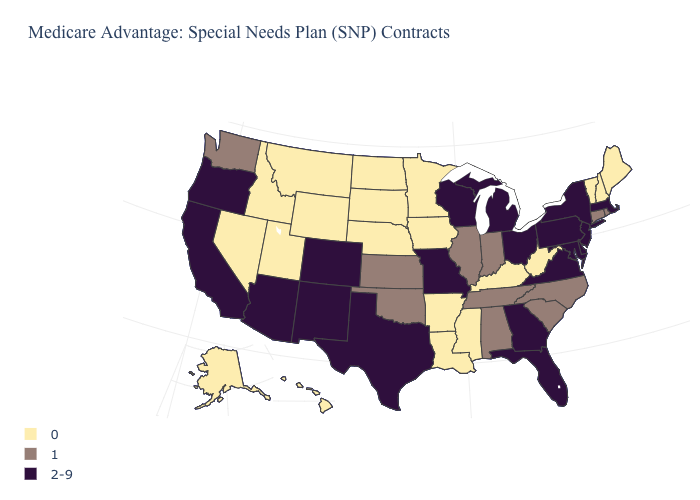Does North Carolina have a lower value than Massachusetts?
Short answer required. Yes. Among the states that border Maryland , which have the highest value?
Short answer required. Delaware, Pennsylvania, Virginia. Name the states that have a value in the range 0?
Quick response, please. Alaska, Arkansas, Hawaii, Iowa, Idaho, Kentucky, Louisiana, Maine, Minnesota, Mississippi, Montana, North Dakota, Nebraska, New Hampshire, Nevada, South Dakota, Utah, Vermont, West Virginia, Wyoming. Name the states that have a value in the range 1?
Keep it brief. Alabama, Connecticut, Illinois, Indiana, Kansas, North Carolina, Oklahoma, Rhode Island, South Carolina, Tennessee, Washington. Name the states that have a value in the range 0?
Be succinct. Alaska, Arkansas, Hawaii, Iowa, Idaho, Kentucky, Louisiana, Maine, Minnesota, Mississippi, Montana, North Dakota, Nebraska, New Hampshire, Nevada, South Dakota, Utah, Vermont, West Virginia, Wyoming. Name the states that have a value in the range 1?
Keep it brief. Alabama, Connecticut, Illinois, Indiana, Kansas, North Carolina, Oklahoma, Rhode Island, South Carolina, Tennessee, Washington. What is the lowest value in states that border Kansas?
Quick response, please. 0. Among the states that border Texas , does Louisiana have the lowest value?
Concise answer only. Yes. Does the first symbol in the legend represent the smallest category?
Short answer required. Yes. What is the lowest value in states that border Massachusetts?
Be succinct. 0. What is the value of Louisiana?
Give a very brief answer. 0. What is the lowest value in the USA?
Write a very short answer. 0. Name the states that have a value in the range 2-9?
Be succinct. Arizona, California, Colorado, Delaware, Florida, Georgia, Massachusetts, Maryland, Michigan, Missouri, New Jersey, New Mexico, New York, Ohio, Oregon, Pennsylvania, Texas, Virginia, Wisconsin. What is the value of Minnesota?
Answer briefly. 0. What is the value of Missouri?
Give a very brief answer. 2-9. 